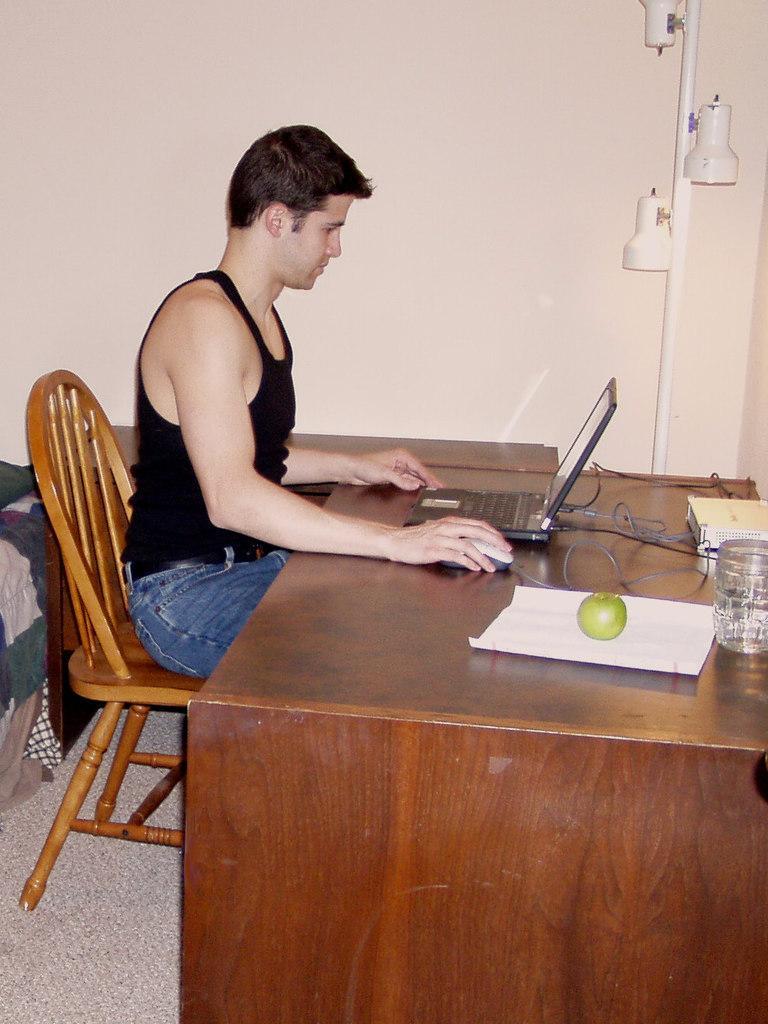Please provide a concise description of this image. There is a person sitting on chair and operating laptop on table and behind him there is a fruit on paper. 